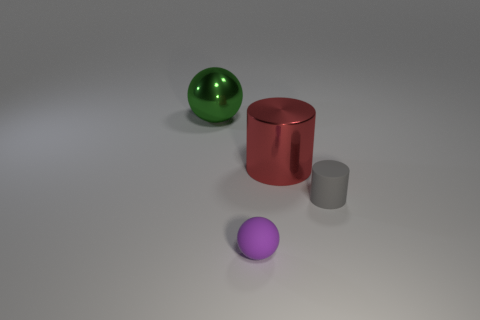Add 1 small objects. How many objects exist? 5 Subtract 0 purple blocks. How many objects are left? 4 Subtract all tiny gray matte cylinders. Subtract all tiny gray rubber cylinders. How many objects are left? 2 Add 2 small purple objects. How many small purple objects are left? 3 Add 1 small purple rubber spheres. How many small purple rubber spheres exist? 2 